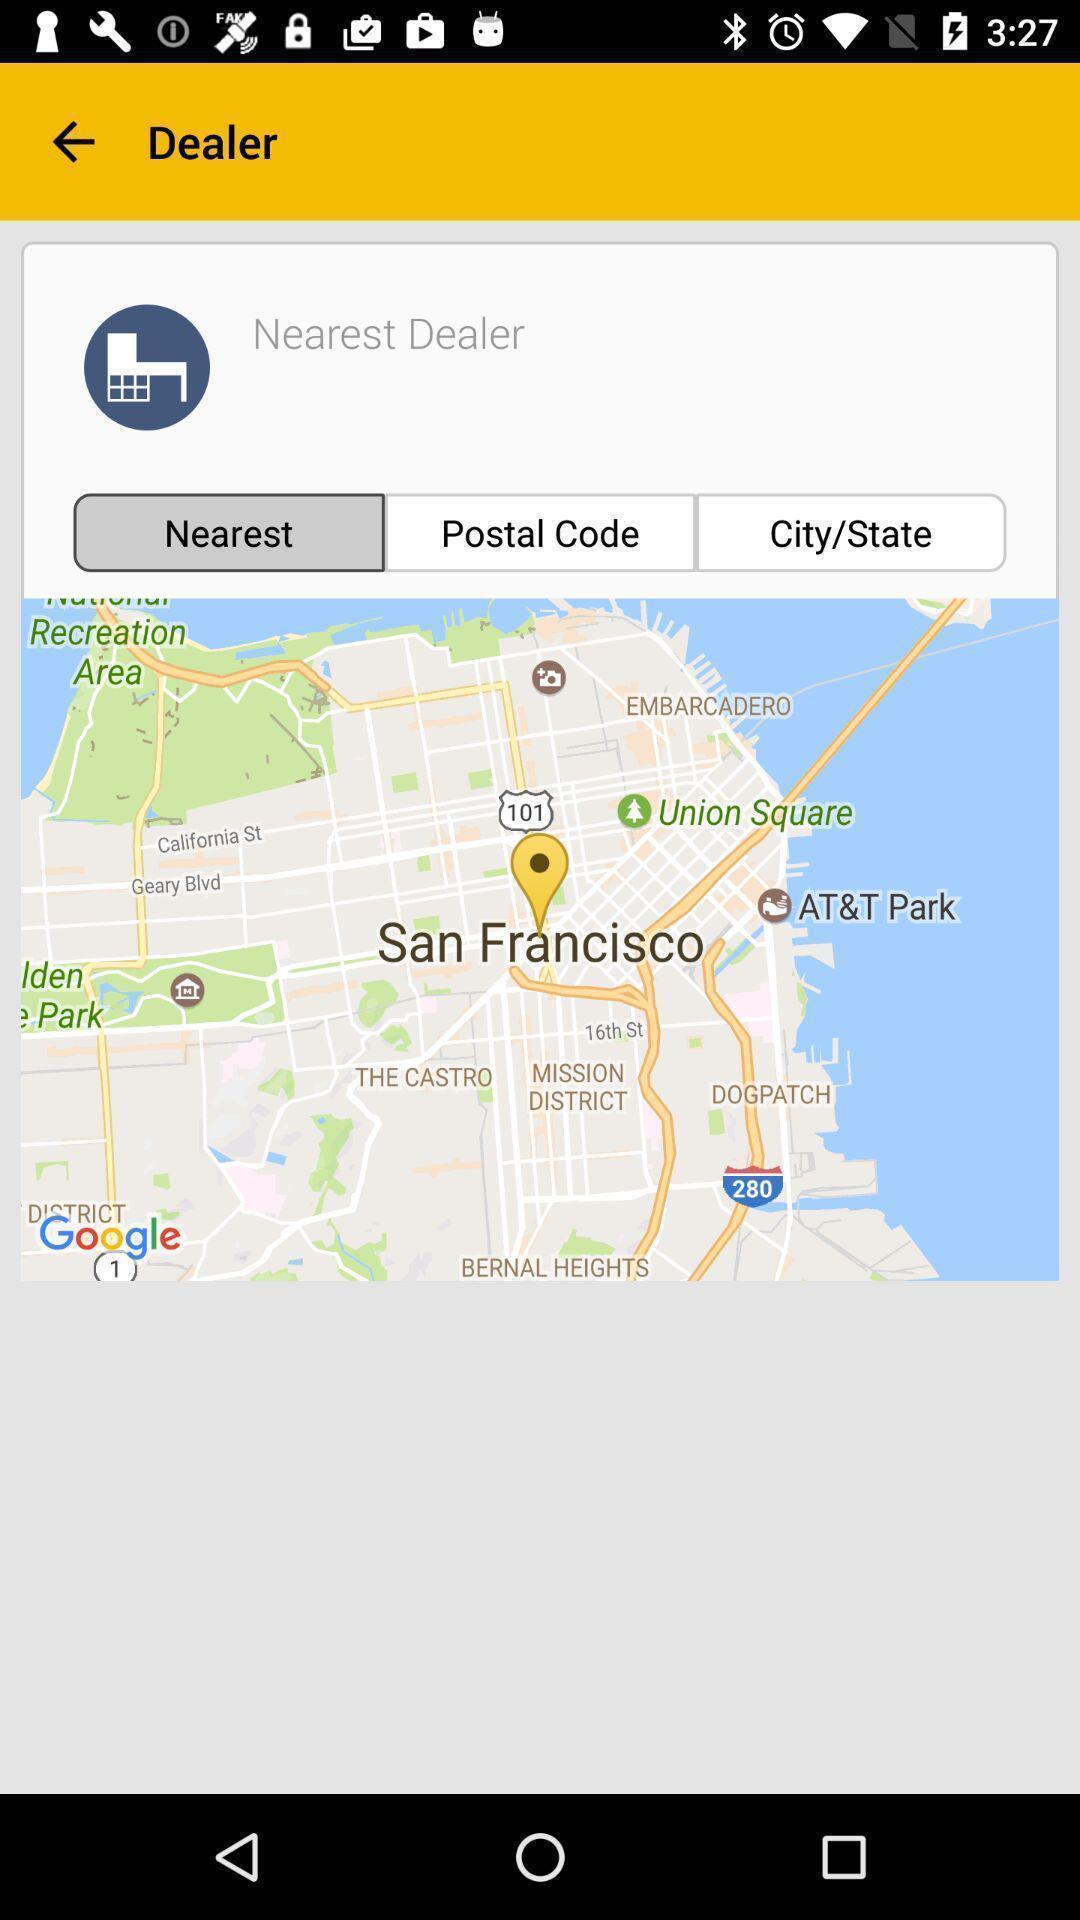Please provide a description for this image. Page displaying the dealer location. 